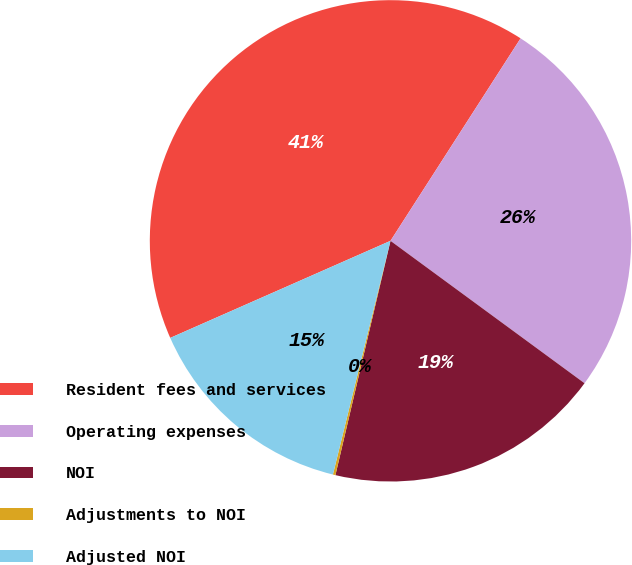Convert chart to OTSL. <chart><loc_0><loc_0><loc_500><loc_500><pie_chart><fcel>Resident fees and services<fcel>Operating expenses<fcel>NOI<fcel>Adjustments to NOI<fcel>Adjusted NOI<nl><fcel>40.7%<fcel>25.99%<fcel>18.6%<fcel>0.17%<fcel>14.55%<nl></chart> 